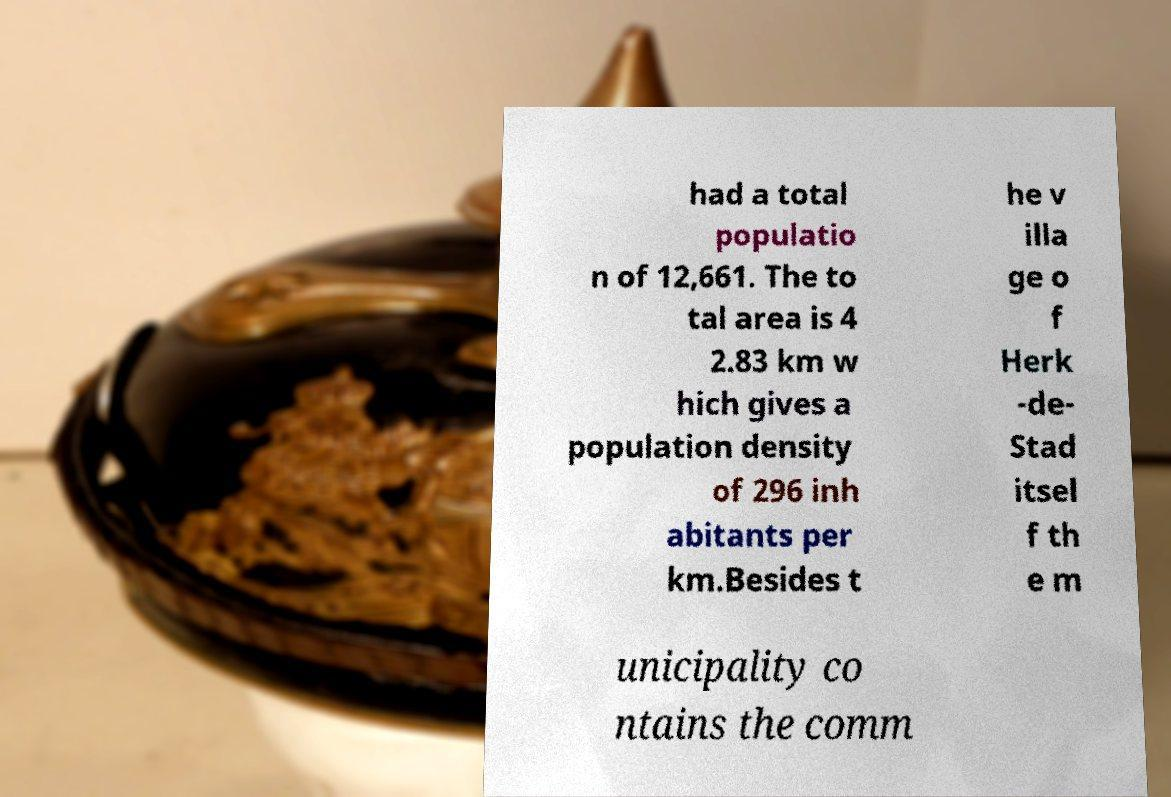Can you accurately transcribe the text from the provided image for me? had a total populatio n of 12,661. The to tal area is 4 2.83 km w hich gives a population density of 296 inh abitants per km.Besides t he v illa ge o f Herk -de- Stad itsel f th e m unicipality co ntains the comm 